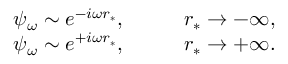<formula> <loc_0><loc_0><loc_500><loc_500>\begin{array} { r l } { \psi _ { \omega } \sim e ^ { - i \omega r _ { * } } , } & \quad r _ { * } \to - \infty , } \\ { \psi _ { \omega } \sim e ^ { + i \omega r _ { * } } , } & \quad r _ { * } \to + \infty . } \end{array}</formula> 